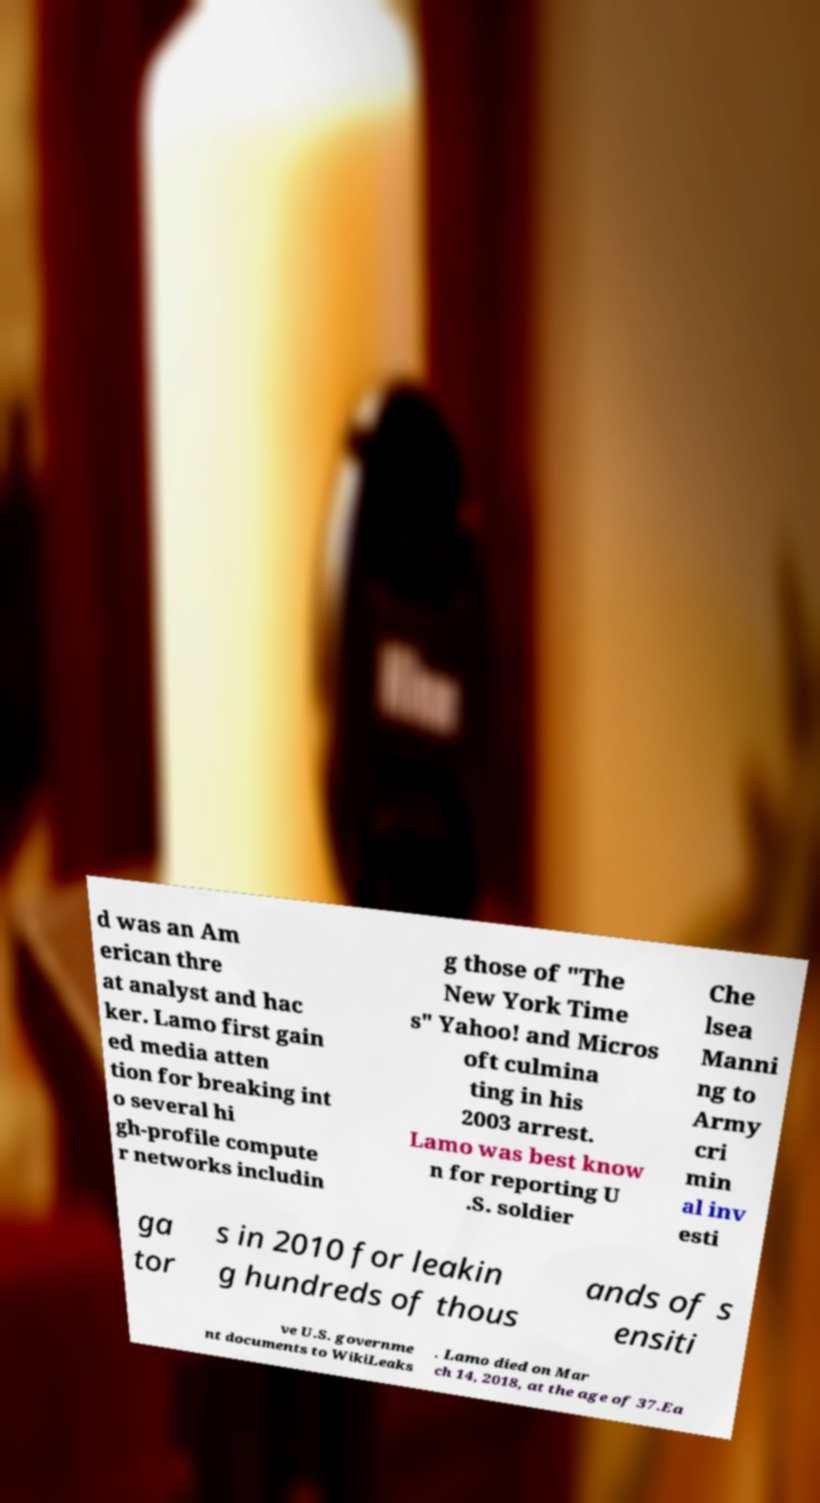There's text embedded in this image that I need extracted. Can you transcribe it verbatim? d was an Am erican thre at analyst and hac ker. Lamo first gain ed media atten tion for breaking int o several hi gh-profile compute r networks includin g those of "The New York Time s" Yahoo! and Micros oft culmina ting in his 2003 arrest. Lamo was best know n for reporting U .S. soldier Che lsea Manni ng to Army cri min al inv esti ga tor s in 2010 for leakin g hundreds of thous ands of s ensiti ve U.S. governme nt documents to WikiLeaks . Lamo died on Mar ch 14, 2018, at the age of 37.Ea 